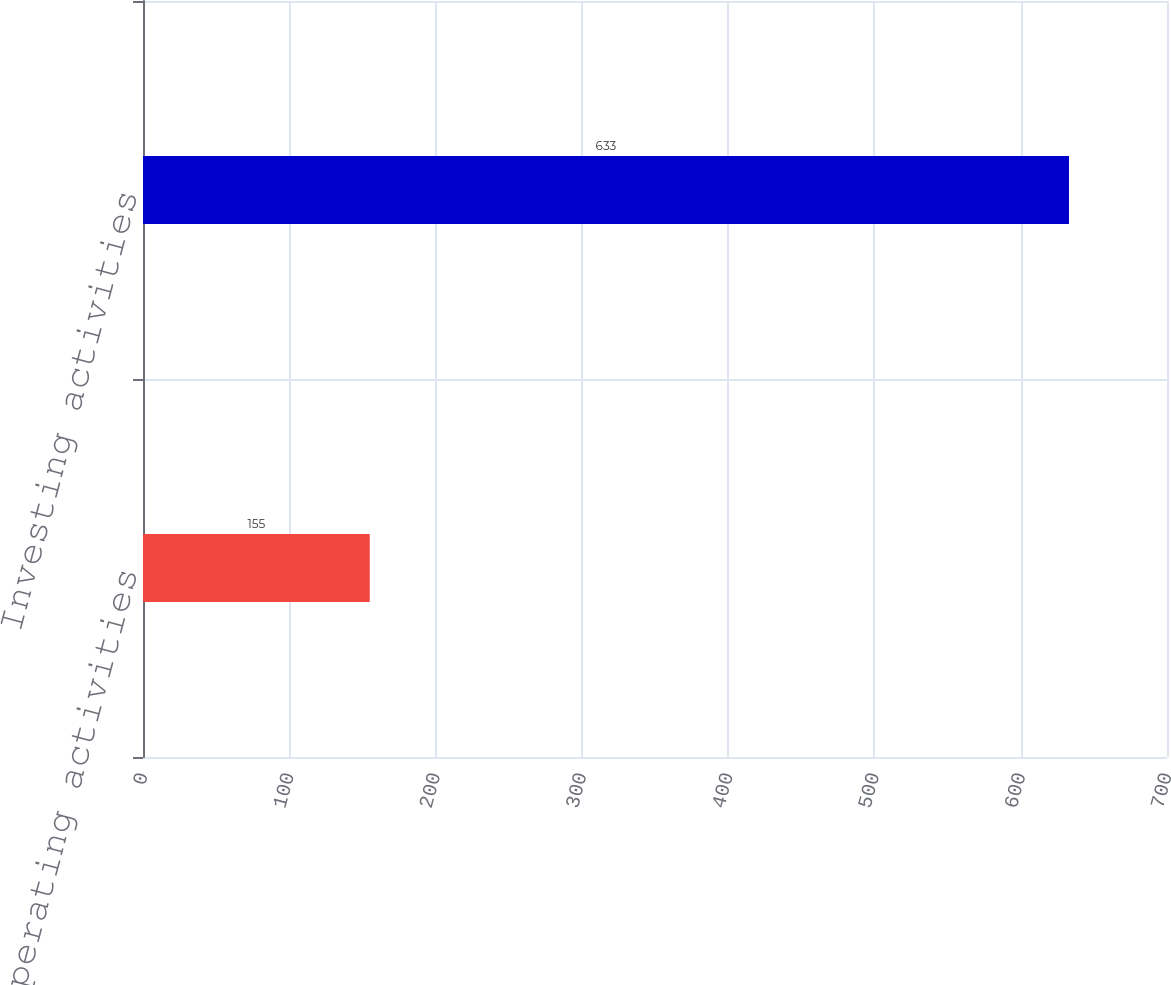<chart> <loc_0><loc_0><loc_500><loc_500><bar_chart><fcel>Operating activities<fcel>Investing activities<nl><fcel>155<fcel>633<nl></chart> 